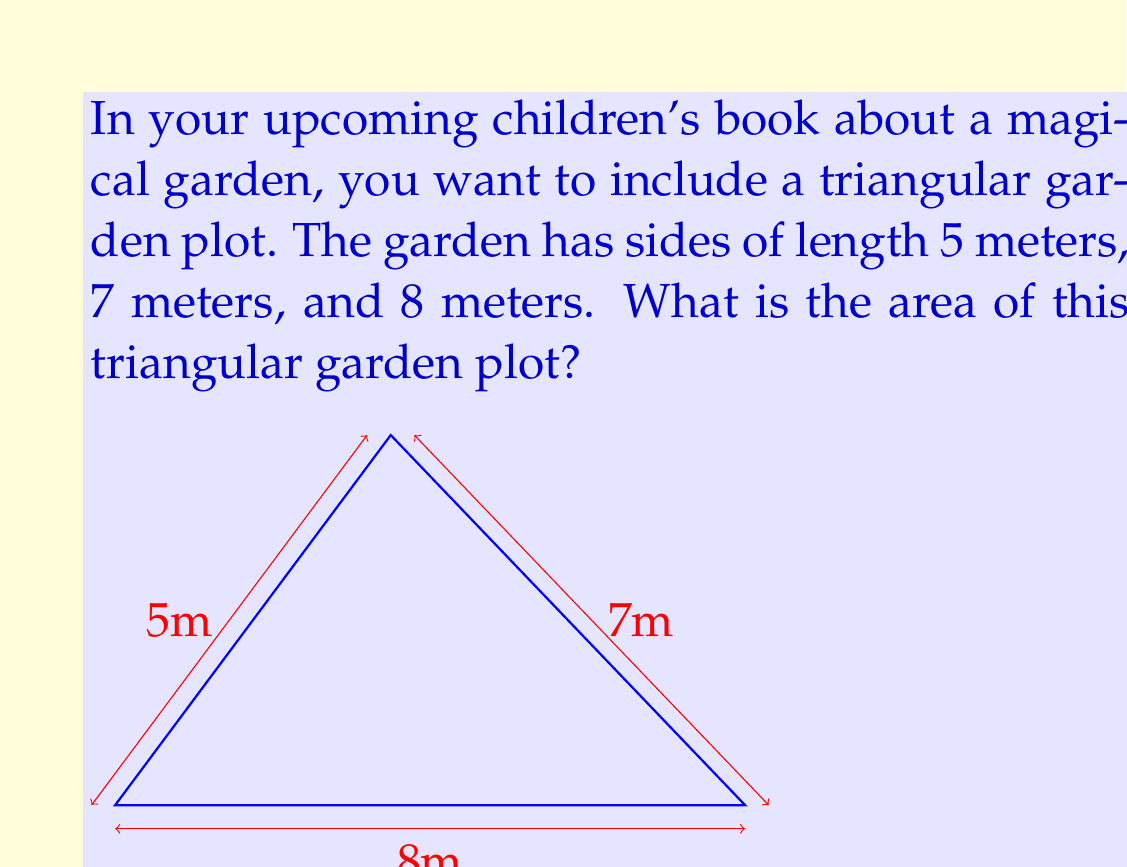Help me with this question. To find the area of a triangle when we know all three side lengths, we can use Heron's formula. Let's follow these steps:

1) First, recall Heron's formula:
   Area = $\sqrt{s(s-a)(s-b)(s-c)}$
   where $s$ is the semi-perimeter, and $a$, $b$, and $c$ are the side lengths.

2) Calculate the semi-perimeter $s$:
   $s = \frac{a + b + c}{2} = \frac{5 + 7 + 8}{2} = \frac{20}{2} = 10$

3) Now, let's substitute these values into Heron's formula:
   Area = $\sqrt{10(10-5)(10-7)(10-8)}$

4) Simplify inside the parentheses:
   Area = $\sqrt{10 \cdot 5 \cdot 3 \cdot 2}$

5) Multiply the numbers under the square root:
   Area = $\sqrt{300}$

6) Simplify the square root:
   Area = $10\sqrt{3}$

Therefore, the area of the triangular garden plot is $10\sqrt{3}$ square meters.
Answer: $10\sqrt{3}$ square meters 